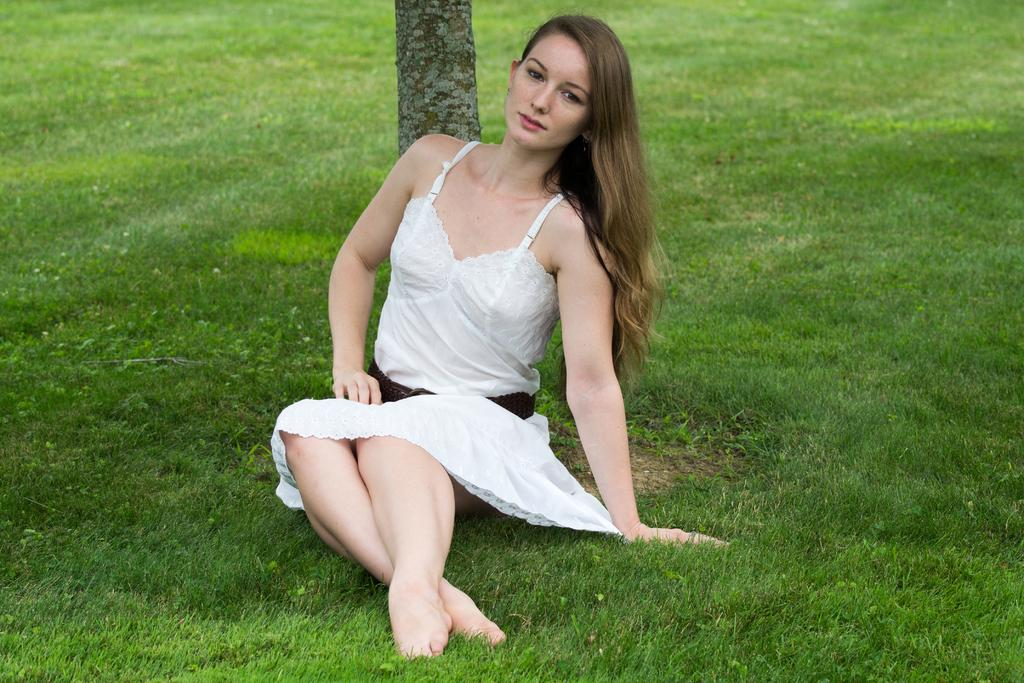Who is the main subject in the image? There is a girl in the center of the image. What is the girl standing on? The girl is standing on a grass floor. What type of environment is depicted in the image? There is grassland surrounding the area in the image. What object is located in the center of the image? There is a trunk in the center of the image. What type of bun is the girl holding in the image? There is no bun present in the image. Can you see a basin in the image? There is no basin present in the image. 